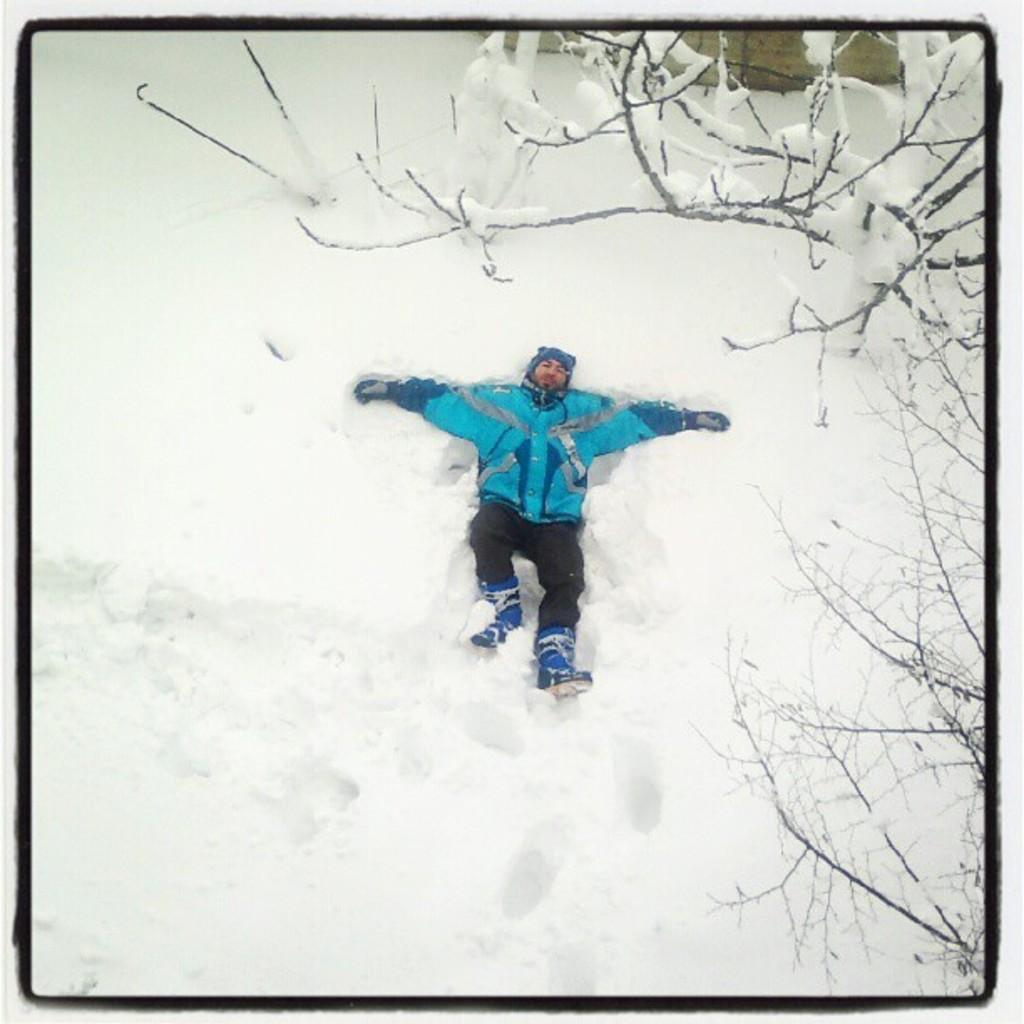What is the man in the image doing? The man is lying on the snow in the image. What type of clothing is the man wearing on his head? The man is wearing a cap. What type of clothing is the man wearing on his upper body? The man is wearing a jerkin. What type of clothing is the man wearing on his lower body? The man is wearing trousers. What type of clothing is the man wearing on his hands? The man is wearing gloves. What type of footwear is the man wearing? The man is wearing shoes. What natural element is present in the image? There is a tree with branches in the image. How is the tree affected by the weather? The tree is partially covered with snow. What type of trains can be seen passing by in the image? There are no trains present in the image; it features a man lying on the snow and a tree partially covered with snow. 